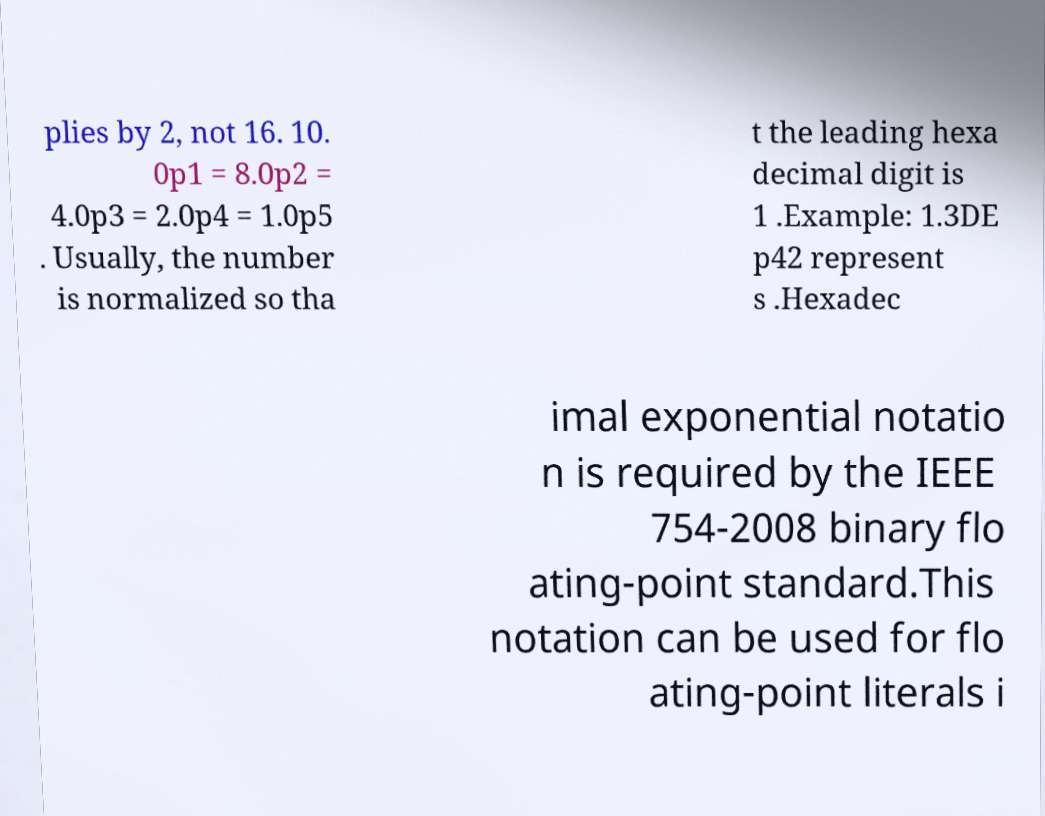Please read and relay the text visible in this image. What does it say? plies by 2, not 16. 10. 0p1 = 8.0p2 = 4.0p3 = 2.0p4 = 1.0p5 . Usually, the number is normalized so tha t the leading hexa decimal digit is 1 .Example: 1.3DE p42 represent s .Hexadec imal exponential notatio n is required by the IEEE 754-2008 binary flo ating-point standard.This notation can be used for flo ating-point literals i 